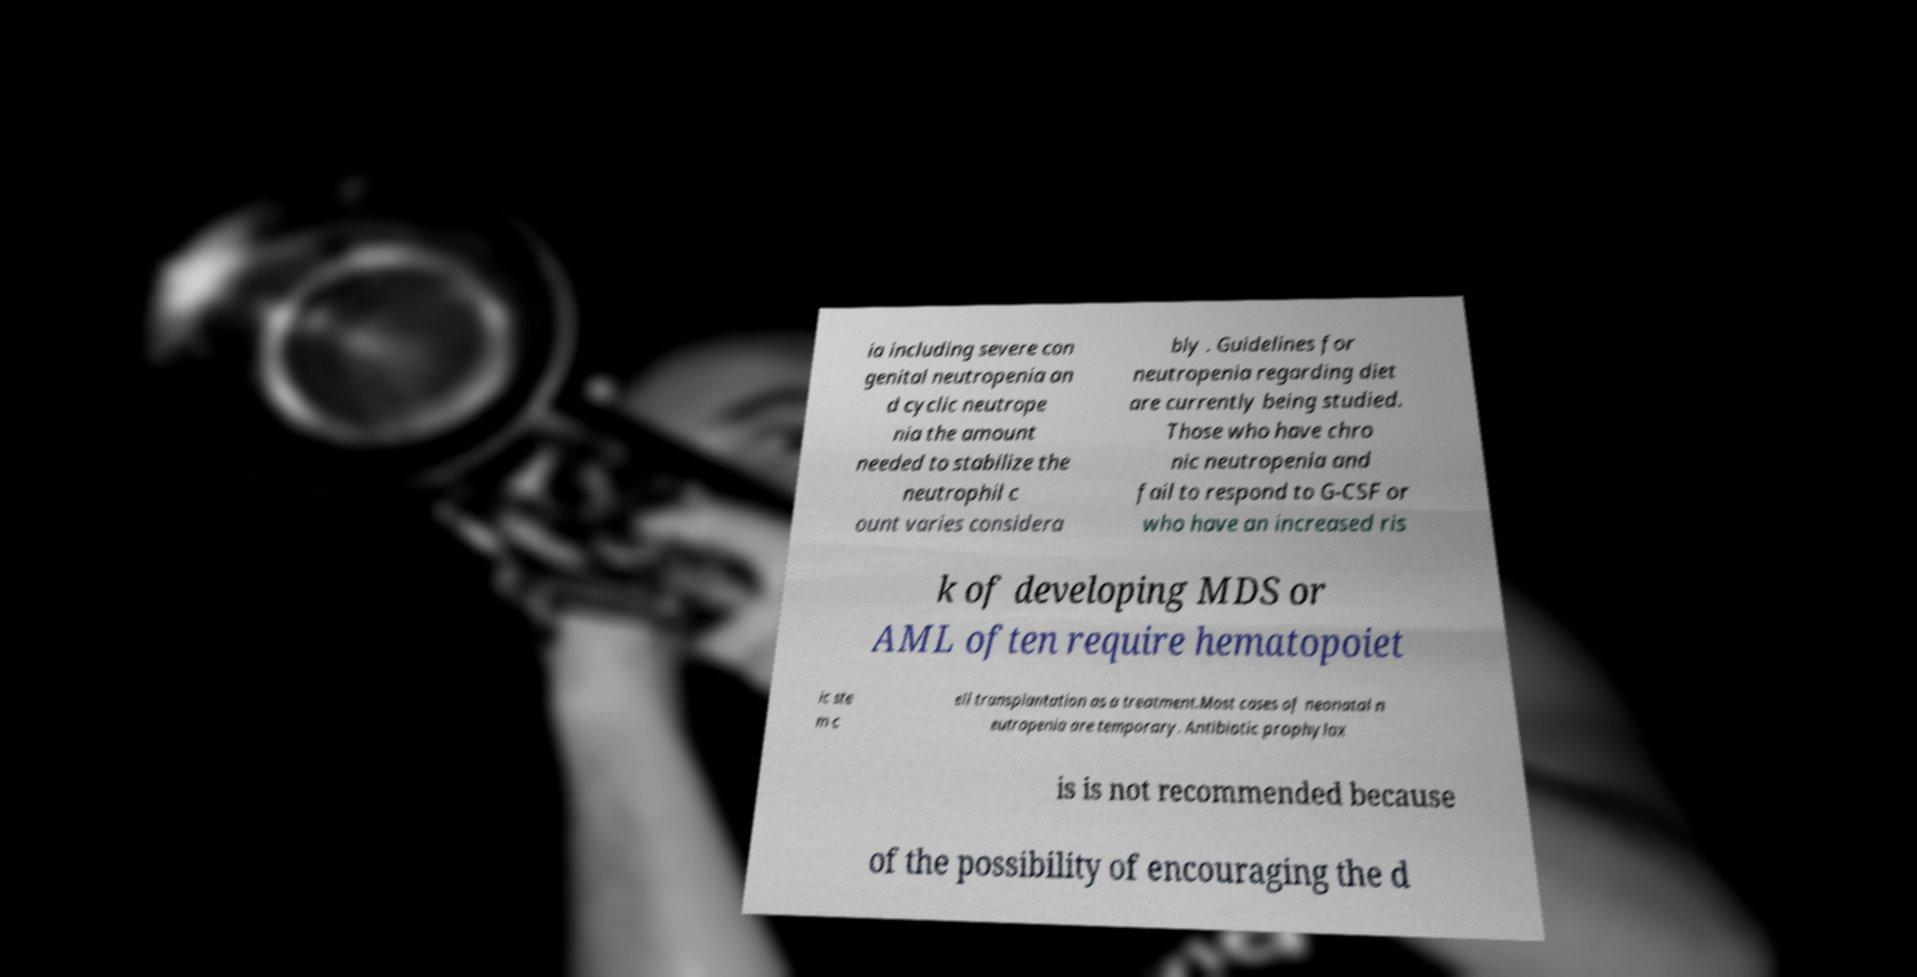Please read and relay the text visible in this image. What does it say? ia including severe con genital neutropenia an d cyclic neutrope nia the amount needed to stabilize the neutrophil c ount varies considera bly . Guidelines for neutropenia regarding diet are currently being studied. Those who have chro nic neutropenia and fail to respond to G-CSF or who have an increased ris k of developing MDS or AML often require hematopoiet ic ste m c ell transplantation as a treatment.Most cases of neonatal n eutropenia are temporary. Antibiotic prophylax is is not recommended because of the possibility of encouraging the d 